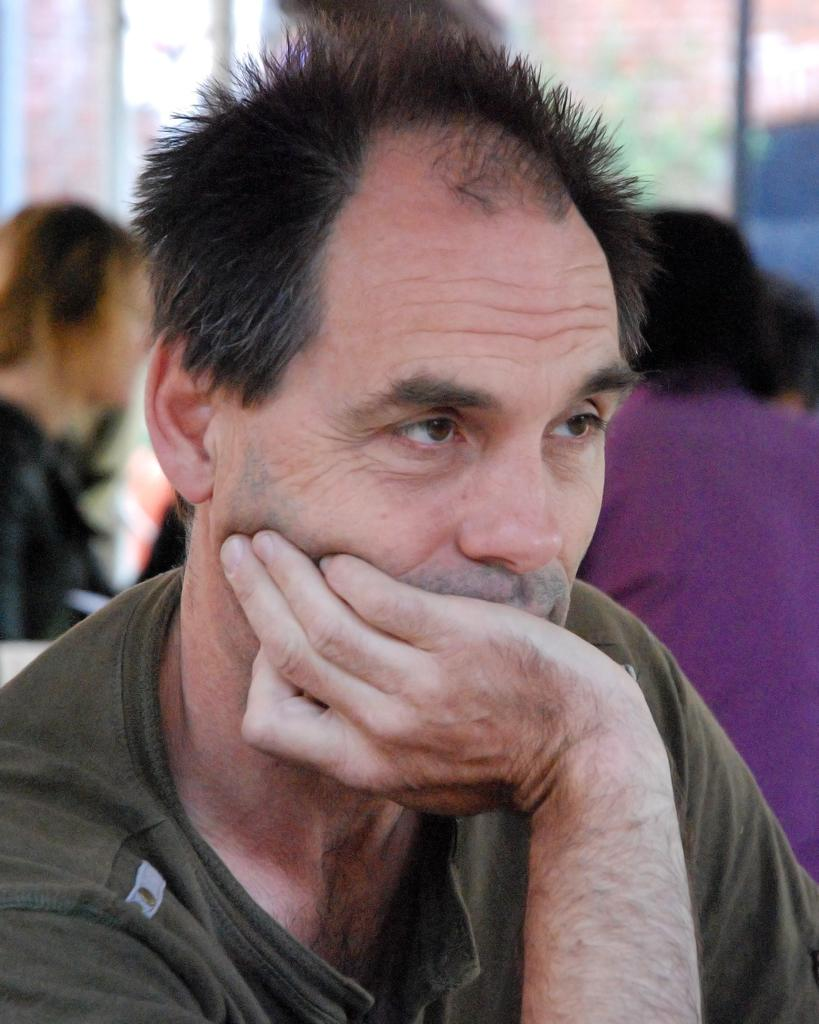Who is present in the image? There is a man in the image. Can you describe the surroundings of the man? There are people in the background of the image. What type of suit is the man wearing in the image? There is no mention of a suit in the provided facts, and the image does not show the man wearing a suit. 